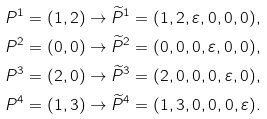<formula> <loc_0><loc_0><loc_500><loc_500>& P ^ { 1 } = ( 1 , 2 ) \rightarrow \widetilde { P } ^ { 1 } = ( 1 , 2 , \varepsilon , 0 , 0 , 0 ) , \\ & P ^ { 2 } = ( 0 , 0 ) \rightarrow \widetilde { P } ^ { 2 } = ( 0 , 0 , 0 , \varepsilon , 0 , 0 ) , \\ & P ^ { 3 } = ( 2 , 0 ) \rightarrow \widetilde { P } ^ { 3 } = ( 2 , 0 , 0 , 0 , \varepsilon , 0 ) , \\ & P ^ { 4 } = ( 1 , 3 ) \rightarrow \widetilde { P } ^ { 4 } = ( 1 , 3 , 0 , 0 , 0 , \varepsilon ) .</formula> 